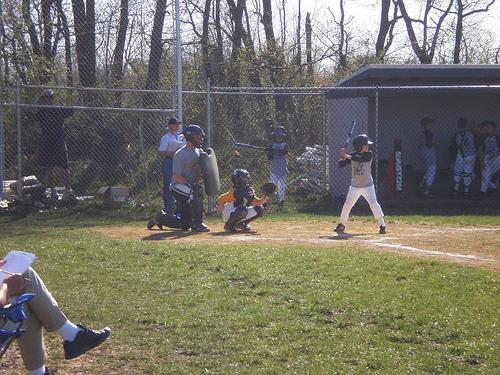Question: what game is being played?
Choices:
A. Football.
B. Baseball.
C. Soccer.
D. Jai Alai.
Answer with the letter. Answer: B Question: when was this picture taken?
Choices:
A. Early evening.
B. Late night.
C. During the day.
D. His birthday.
Answer with the letter. Answer: C Question: why does the catcher wear pads?
Choices:
A. Protection.
B. Style.
C. Regulation.
D. He Doesn't.
Answer with the letter. Answer: A Question: what is in the background?
Choices:
A. Clouds.
B. Sky.
C. Spectators.
D. Trees.
Answer with the letter. Answer: D Question: where was this picture taken?
Choices:
A. A skatepark.
B. A baseball field.
C. The beach.
D. Football field.
Answer with the letter. Answer: B 